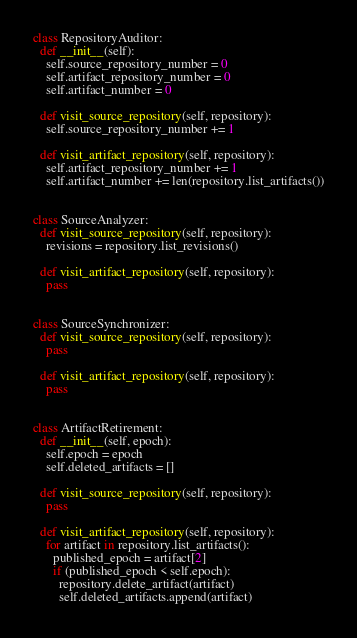<code> <loc_0><loc_0><loc_500><loc_500><_Python_>class RepositoryAuditor:
  def __init__(self):
    self.source_repository_number = 0
    self.artifact_repository_number = 0
    self.artifact_number = 0

  def visit_source_repository(self, repository):
    self.source_repository_number += 1

  def visit_artifact_repository(self, repository):
    self.artifact_repository_number += 1
    self.artifact_number += len(repository.list_artifacts())


class SourceAnalyzer:
  def visit_source_repository(self, repository):
    revisions = repository.list_revisions()

  def visit_artifact_repository(self, repository):
    pass


class SourceSynchronizer:
  def visit_source_repository(self, repository):
    pass

  def visit_artifact_repository(self, repository):
    pass


class ArtifactRetirement:
  def __init__(self, epoch):
    self.epoch = epoch
    self.deleted_artifacts = []

  def visit_source_repository(self, repository):
    pass

  def visit_artifact_repository(self, repository):
    for artifact in repository.list_artifacts():
      published_epoch = artifact[2]
      if (published_epoch < self.epoch):
        repository.delete_artifact(artifact)
        self.deleted_artifacts.append(artifact)
</code> 